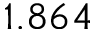<formula> <loc_0><loc_0><loc_500><loc_500>1 . 8 6 4</formula> 